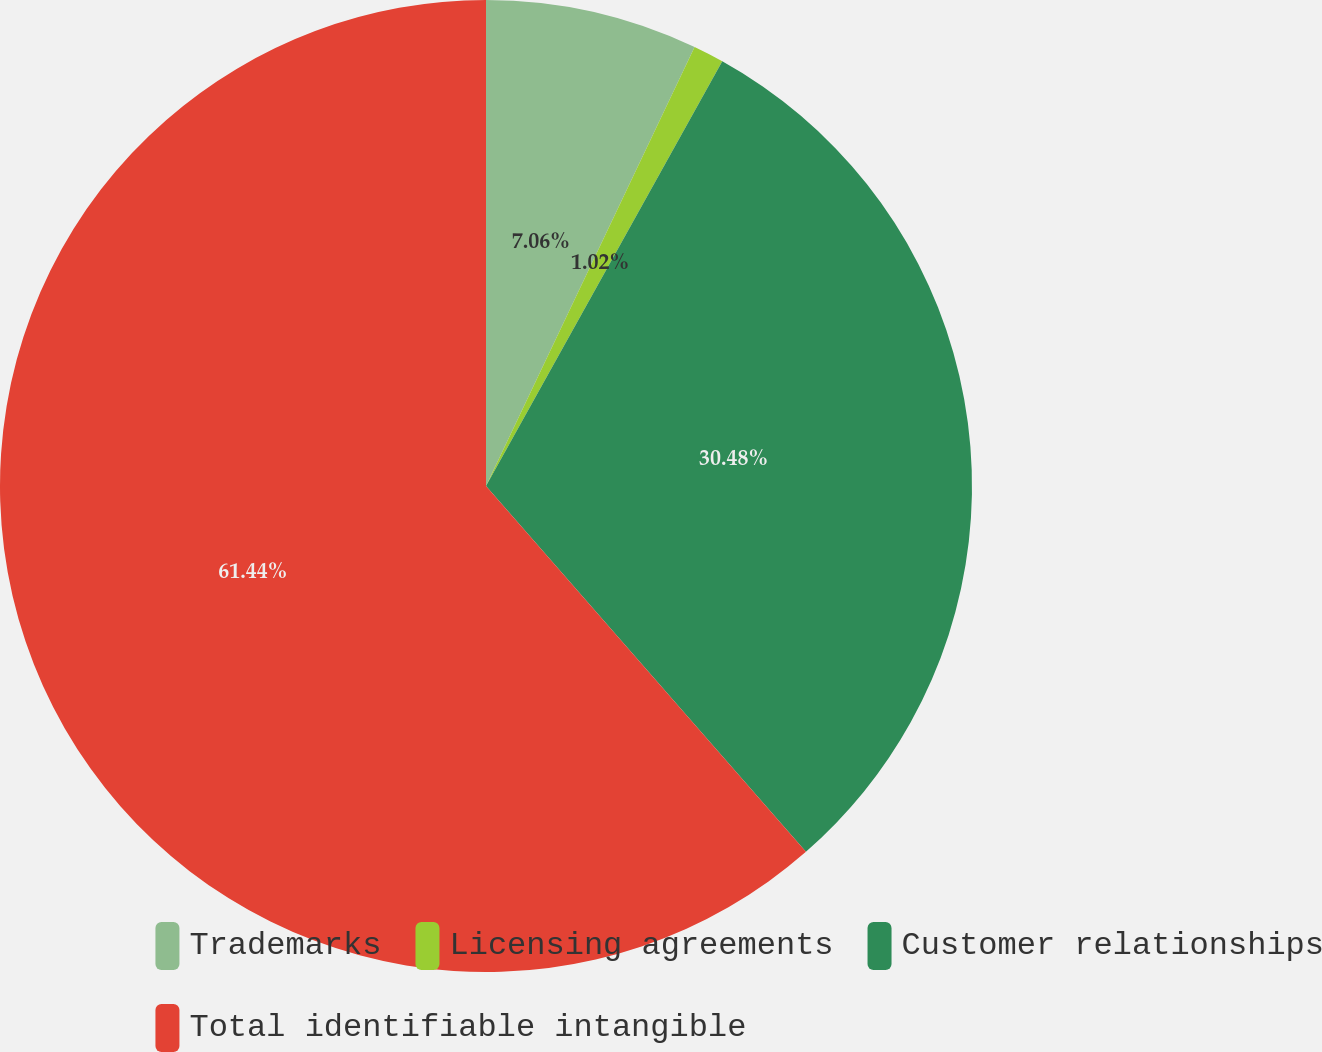<chart> <loc_0><loc_0><loc_500><loc_500><pie_chart><fcel>Trademarks<fcel>Licensing agreements<fcel>Customer relationships<fcel>Total identifiable intangible<nl><fcel>7.06%<fcel>1.02%<fcel>30.48%<fcel>61.43%<nl></chart> 